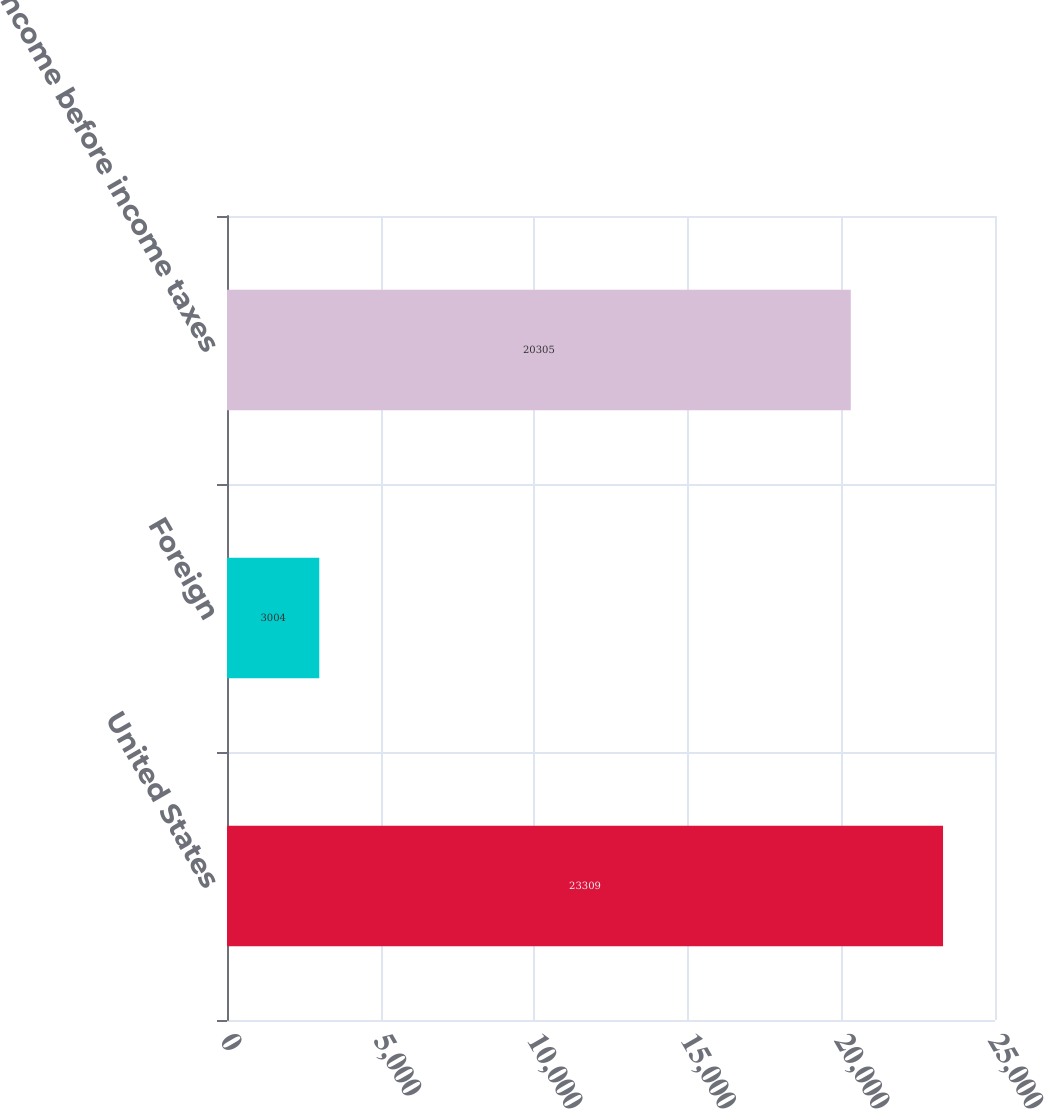Convert chart. <chart><loc_0><loc_0><loc_500><loc_500><bar_chart><fcel>United States<fcel>Foreign<fcel>Income before income taxes<nl><fcel>23309<fcel>3004<fcel>20305<nl></chart> 